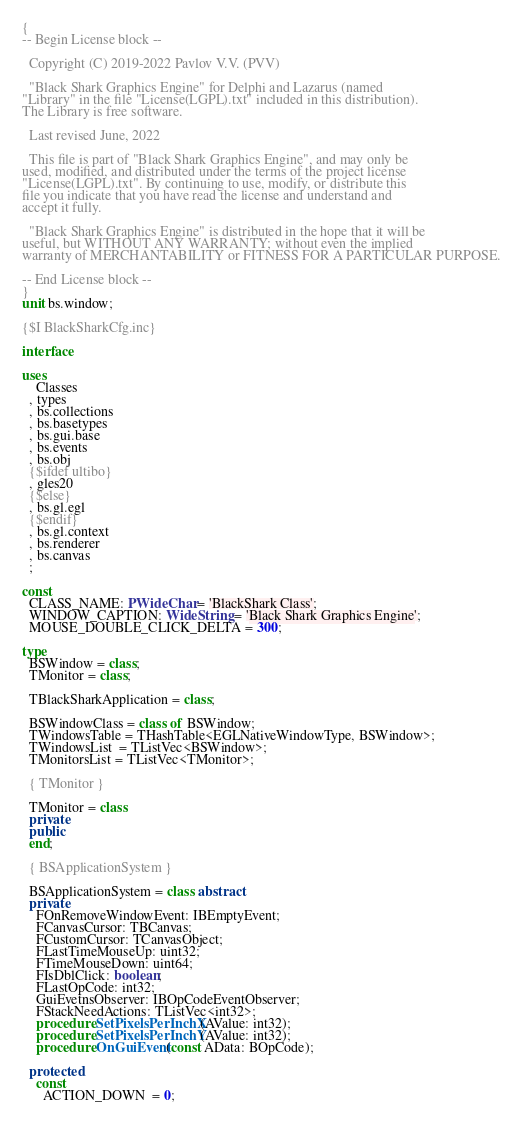<code> <loc_0><loc_0><loc_500><loc_500><_Pascal_>{
-- Begin License block --
  
  Copyright (C) 2019-2022 Pavlov V.V. (PVV)

  "Black Shark Graphics Engine" for Delphi and Lazarus (named 
"Library" in the file "License(LGPL).txt" included in this distribution). 
The Library is free software.

  Last revised June, 2022

  This file is part of "Black Shark Graphics Engine", and may only be
used, modified, and distributed under the terms of the project license 
"License(LGPL).txt". By continuing to use, modify, or distribute this
file you indicate that you have read the license and understand and 
accept it fully.

  "Black Shark Graphics Engine" is distributed in the hope that it will be 
useful, but WITHOUT ANY WARRANTY; without even the implied 
warranty of MERCHANTABILITY or FITNESS FOR A PARTICULAR PURPOSE. 

-- End License block --
}
unit bs.window;

{$I BlackSharkCfg.inc}

interface

uses
    Classes
  , types
  , bs.collections
  , bs.basetypes
  , bs.gui.base
  , bs.events
  , bs.obj
  {$ifdef ultibo}
  , gles20
  {$else}
  , bs.gl.egl
  {$endif}
  , bs.gl.context
  , bs.renderer
  , bs.canvas
  ;

const
  CLASS_NAME: PWideChar = 'BlackShark Class';
  WINDOW_CAPTION: WideString = 'Black Shark Graphics Engine';
  MOUSE_DOUBLE_CLICK_DELTA = 300;

type
  BSWindow = class;
  TMonitor = class;

  TBlackSharkApplication = class;

  BSWindowClass = class of BSWindow;
  TWindowsTable = THashTable<EGLNativeWindowType, BSWindow>;
  TWindowsList  = TListVec<BSWindow>;
  TMonitorsList = TListVec<TMonitor>;

  { TMonitor }

  TMonitor = class
  private
  public
  end;

  { BSApplicationSystem }

  BSApplicationSystem = class abstract
  private
    FOnRemoveWindowEvent: IBEmptyEvent;
    FCanvasCursor: TBCanvas;
    FCustomCursor: TCanvasObject;
    FLastTimeMouseUp: uint32;
    FTimeMouseDown: uint64;
    FIsDblClick: boolean;
    FLastOpCode: int32;
    GuiEvetnsObserver: IBOpCodeEventObserver;
    FStackNeedActions: TListVec<int32>;
    procedure SetPixelsPerInchX(AValue: int32);
    procedure SetPixelsPerInchY(AValue: int32);
    procedure OnGuiEvent(const AData: BOpCode);

  protected
    const
      ACTION_DOWN  = 0;</code> 